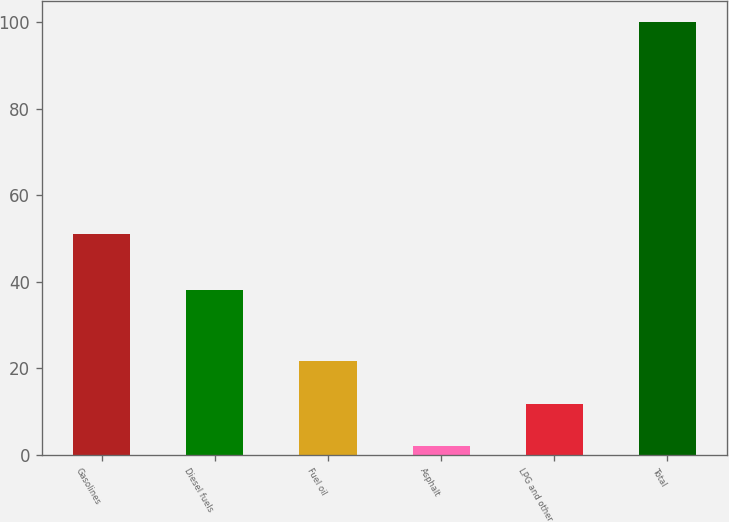<chart> <loc_0><loc_0><loc_500><loc_500><bar_chart><fcel>Gasolines<fcel>Diesel fuels<fcel>Fuel oil<fcel>Asphalt<fcel>LPG and other<fcel>Total<nl><fcel>51<fcel>38<fcel>21.6<fcel>2<fcel>11.8<fcel>100<nl></chart> 